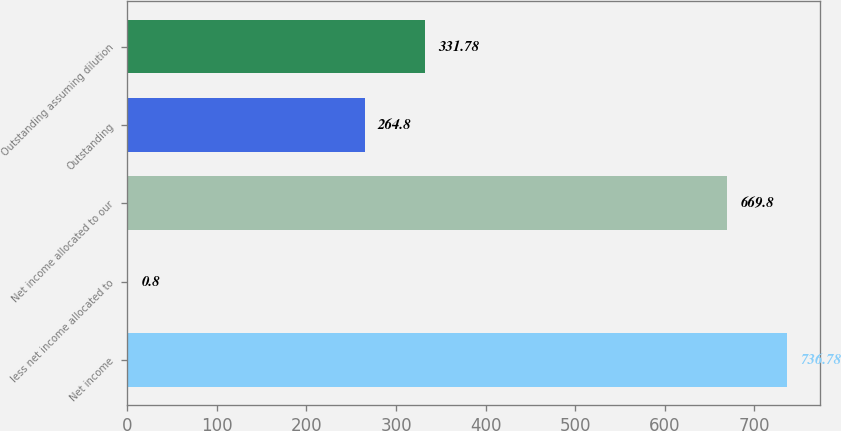<chart> <loc_0><loc_0><loc_500><loc_500><bar_chart><fcel>Net income<fcel>less net income allocated to<fcel>Net income allocated to our<fcel>Outstanding<fcel>Outstanding assuming dilution<nl><fcel>736.78<fcel>0.8<fcel>669.8<fcel>264.8<fcel>331.78<nl></chart> 